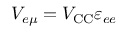Convert formula to latex. <formula><loc_0><loc_0><loc_500><loc_500>V _ { e \mu } = V _ { C C } \varepsilon _ { e e }</formula> 